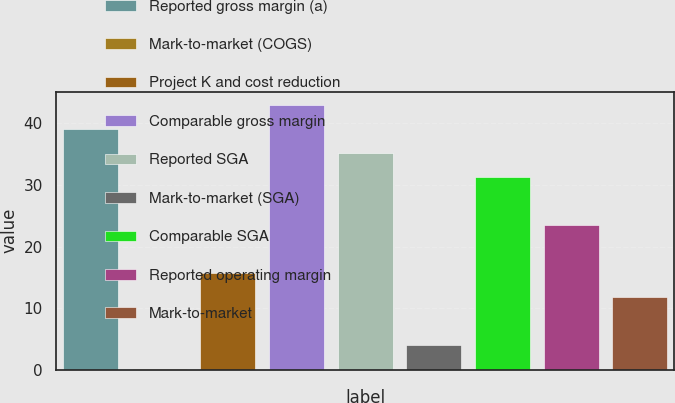Convert chart. <chart><loc_0><loc_0><loc_500><loc_500><bar_chart><fcel>Reported gross margin (a)<fcel>Mark-to-market (COGS)<fcel>Project K and cost reduction<fcel>Comparable gross margin<fcel>Reported SGA<fcel>Mark-to-market (SGA)<fcel>Comparable SGA<fcel>Reported operating margin<fcel>Mark-to-market<nl><fcel>39.1<fcel>0.1<fcel>15.7<fcel>43<fcel>35.2<fcel>4<fcel>31.3<fcel>23.5<fcel>11.8<nl></chart> 